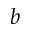<formula> <loc_0><loc_0><loc_500><loc_500>b</formula> 